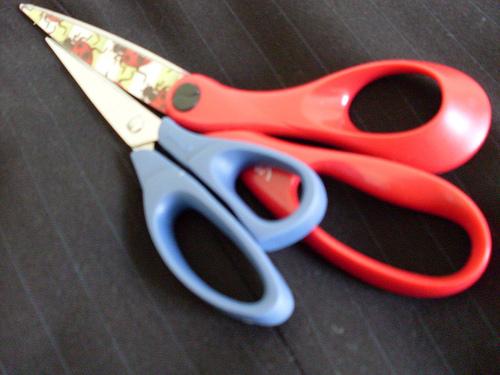Are the scissors stainless?
Write a very short answer. Yes. What is on top of the scissors?
Keep it brief. Scissors. What is the pattern on the blades of the red scissors?
Give a very brief answer. Ladybug. How many pairs of scissors in the picture?
Write a very short answer. 2. 